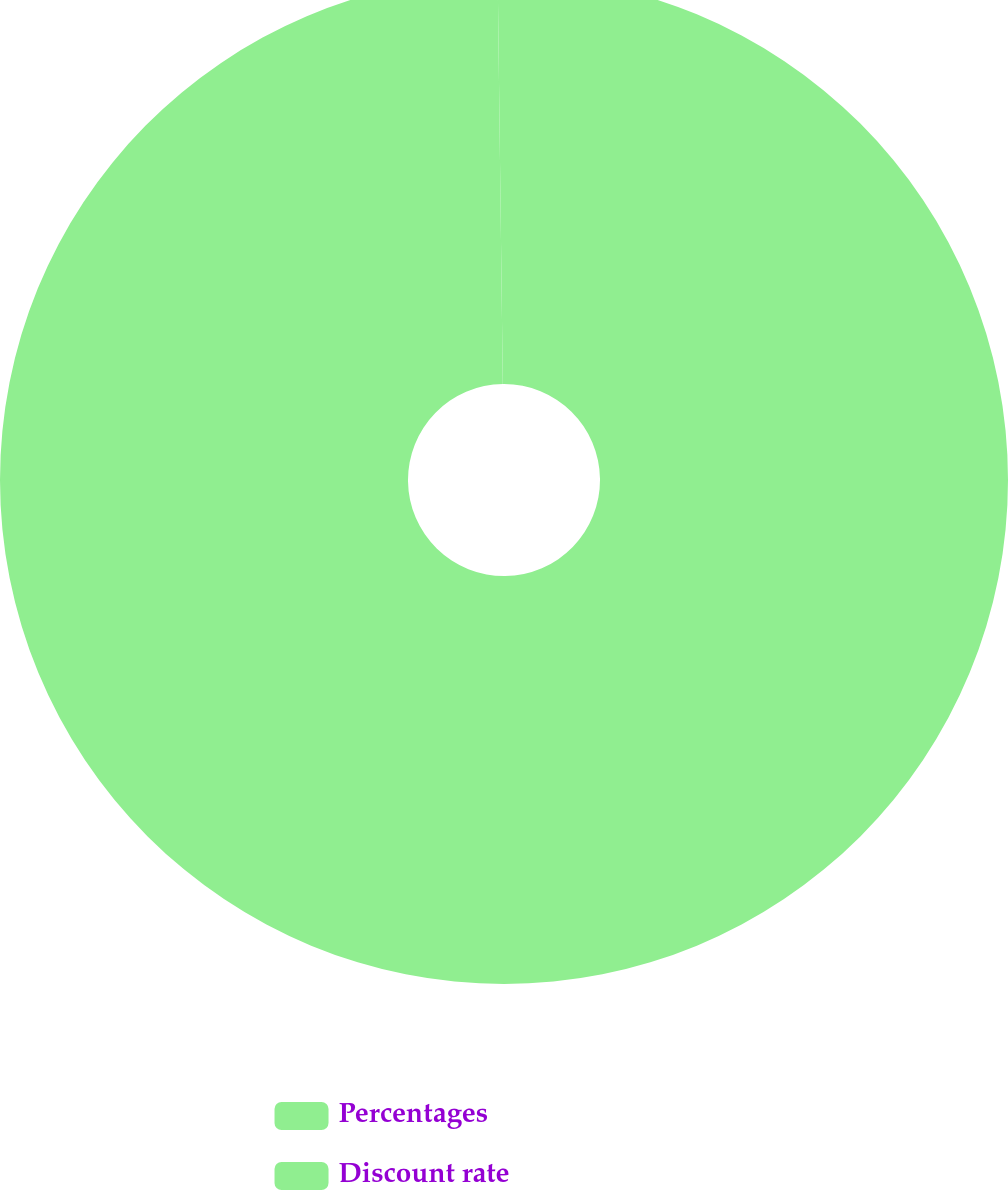<chart> <loc_0><loc_0><loc_500><loc_500><pie_chart><fcel>Percentages<fcel>Discount rate<nl><fcel>99.8%<fcel>0.2%<nl></chart> 